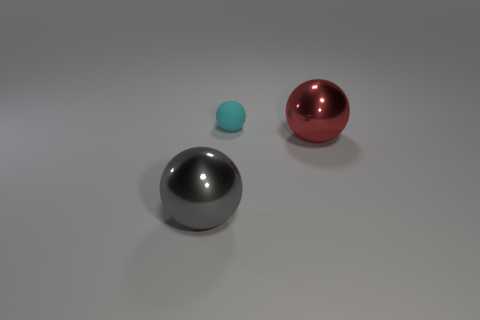Add 3 big gray metal things. How many objects exist? 6 Subtract all large balls. How many balls are left? 1 Subtract all gray balls. How many balls are left? 2 Add 1 small matte spheres. How many small matte spheres are left? 2 Add 1 large gray objects. How many large gray objects exist? 2 Subtract 0 purple cylinders. How many objects are left? 3 Subtract 3 balls. How many balls are left? 0 Subtract all gray balls. Subtract all blue cubes. How many balls are left? 2 Subtract all yellow cylinders. How many gray spheres are left? 1 Subtract all tiny spheres. Subtract all blue objects. How many objects are left? 2 